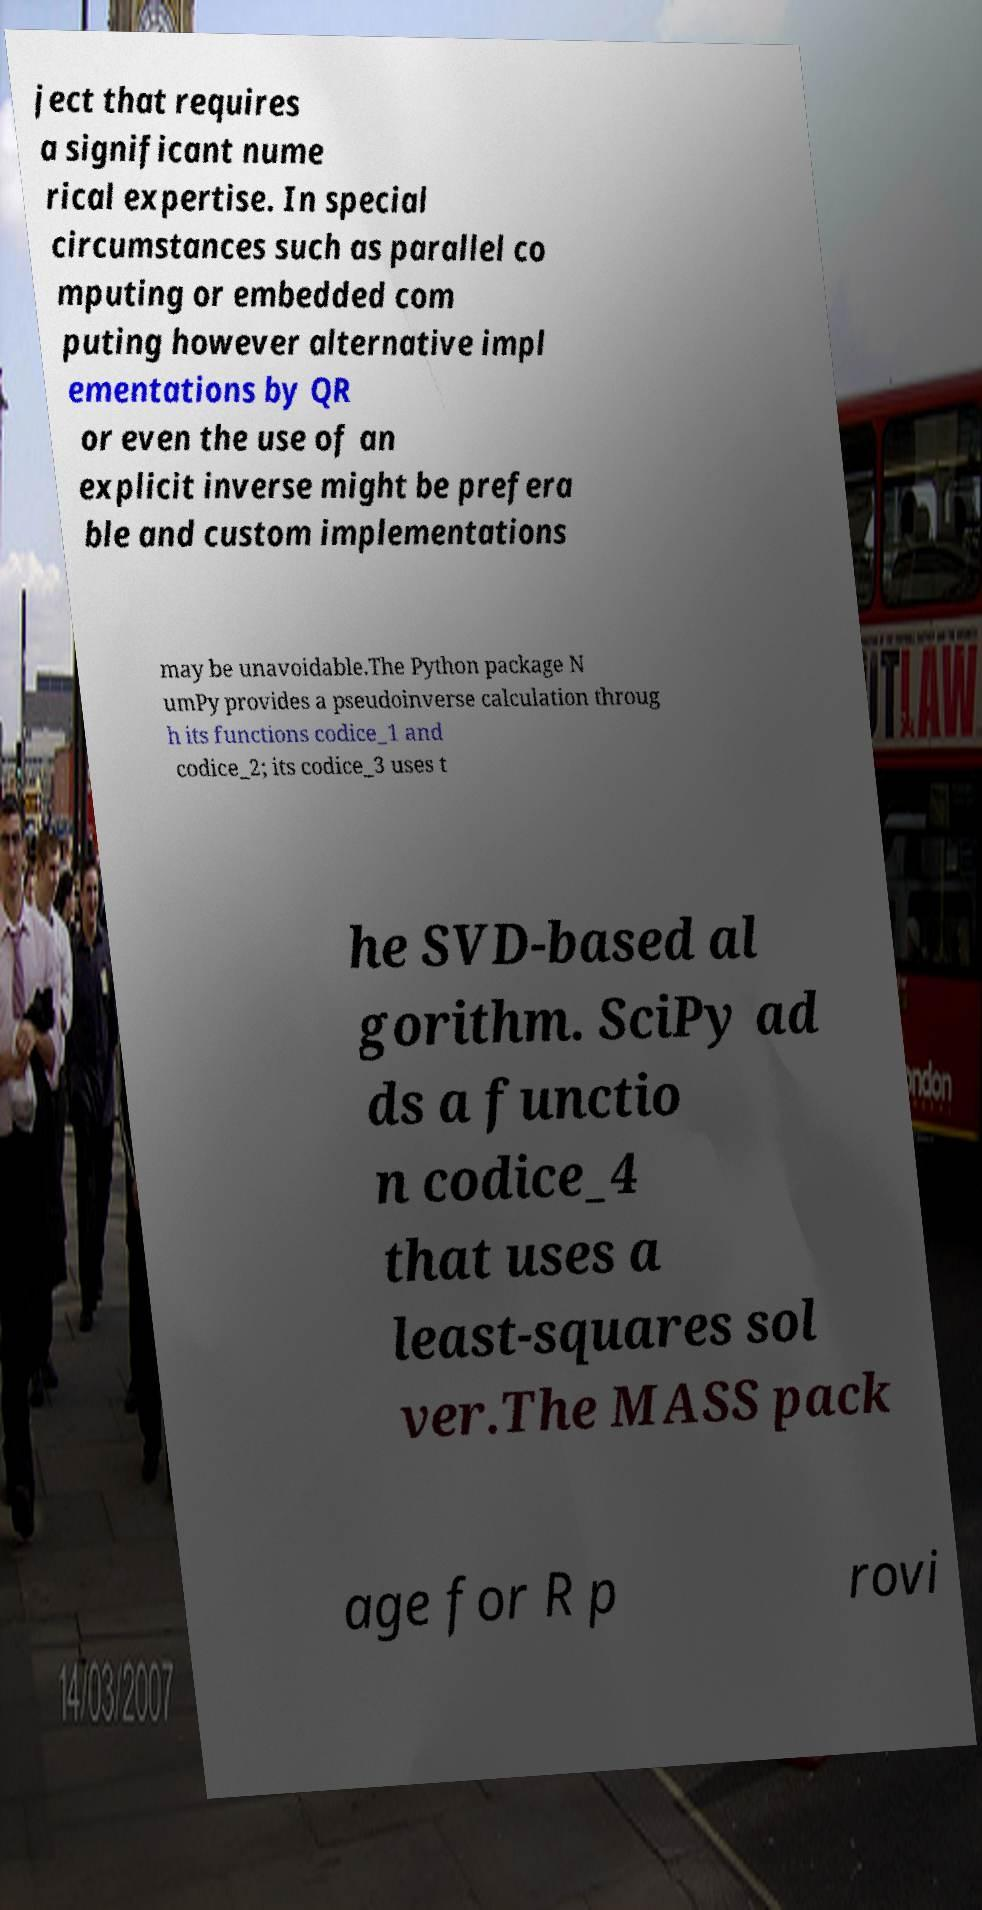Could you extract and type out the text from this image? ject that requires a significant nume rical expertise. In special circumstances such as parallel co mputing or embedded com puting however alternative impl ementations by QR or even the use of an explicit inverse might be prefera ble and custom implementations may be unavoidable.The Python package N umPy provides a pseudoinverse calculation throug h its functions codice_1 and codice_2; its codice_3 uses t he SVD-based al gorithm. SciPy ad ds a functio n codice_4 that uses a least-squares sol ver.The MASS pack age for R p rovi 